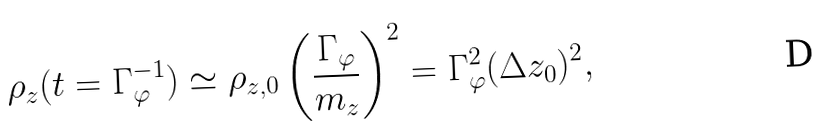Convert formula to latex. <formula><loc_0><loc_0><loc_500><loc_500>\rho _ { z } ( t = \Gamma _ { \varphi } ^ { - 1 } ) \simeq \rho _ { z , 0 } \left ( \frac { \Gamma _ { \varphi } } { m _ { z } } \right ) ^ { 2 } = \Gamma _ { \varphi } ^ { 2 } ( \Delta z _ { 0 } ) ^ { 2 } ,</formula> 